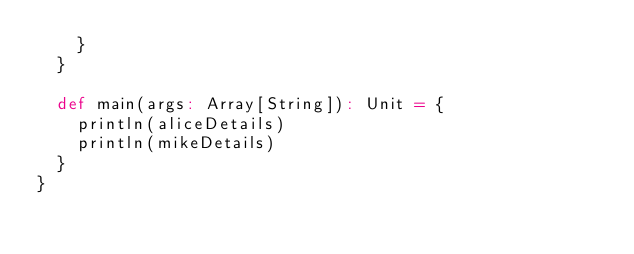Convert code to text. <code><loc_0><loc_0><loc_500><loc_500><_Scala_>    }
  }

  def main(args: Array[String]): Unit = {
    println(aliceDetails)
    println(mikeDetails)
  }
}
</code> 